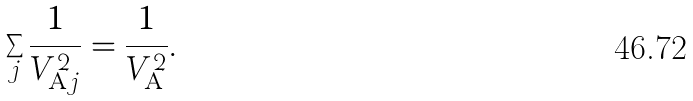<formula> <loc_0><loc_0><loc_500><loc_500>\sum _ { j } \frac { 1 } { V ^ { 2 } _ { \mathrm A j } } = \frac { 1 } { V ^ { 2 } _ { \mathrm A } } .</formula> 